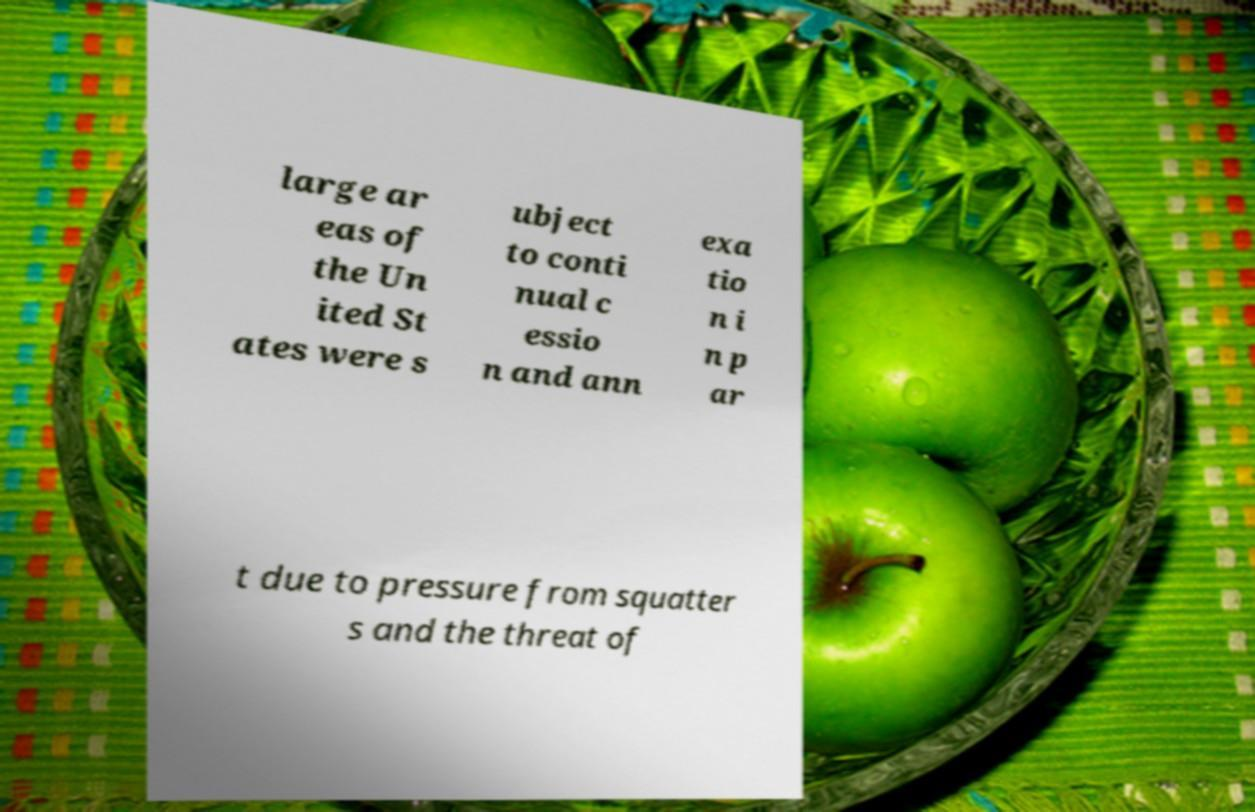For documentation purposes, I need the text within this image transcribed. Could you provide that? large ar eas of the Un ited St ates were s ubject to conti nual c essio n and ann exa tio n i n p ar t due to pressure from squatter s and the threat of 